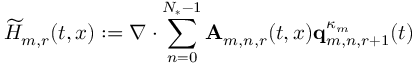<formula> <loc_0><loc_0><loc_500><loc_500>\widetilde { H } _ { m , r } ( t , x ) \colon = \nabla \cdot \sum _ { n = 0 } ^ { N _ { * } - 1 } A _ { m , n , r } ( t , x ) q _ { m , n , r + 1 } ^ { \kappa _ { m } } ( t )</formula> 